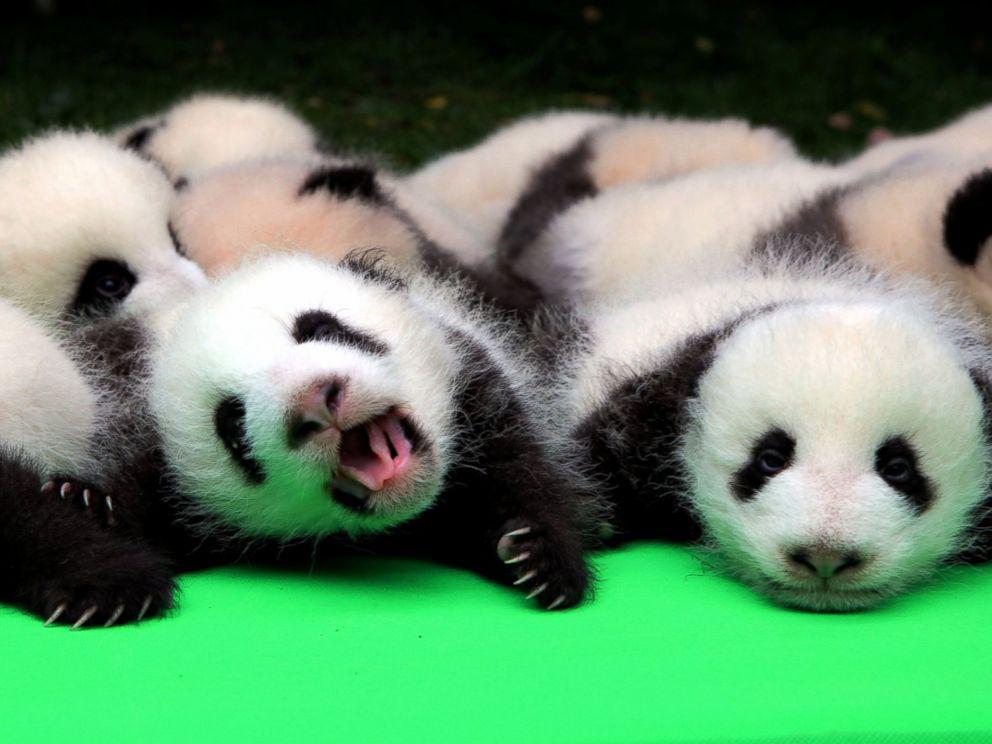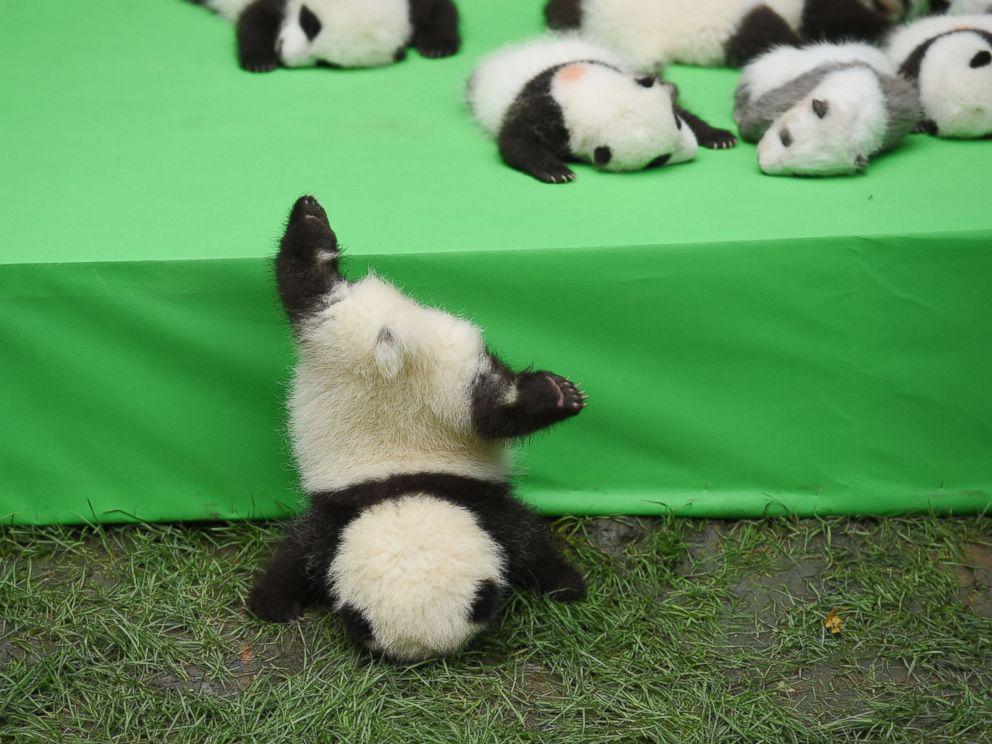The first image is the image on the left, the second image is the image on the right. Assess this claim about the two images: "At least one image shows multiple pandas piled on a flat green surface resembling a tablecloth.". Correct or not? Answer yes or no. Yes. The first image is the image on the left, the second image is the image on the right. Considering the images on both sides, is "Both images show only baby pandas and no adult pandas." valid? Answer yes or no. Yes. 